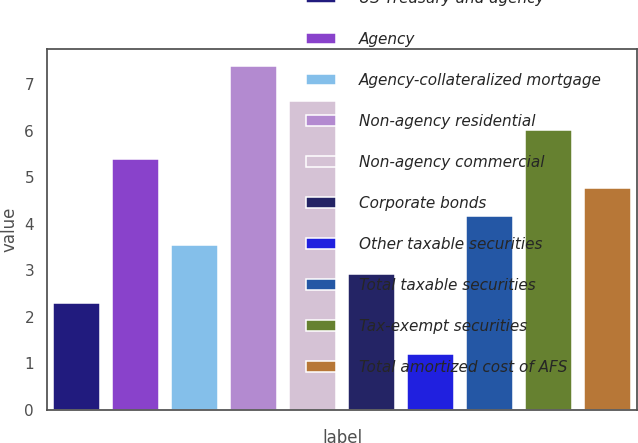Convert chart. <chart><loc_0><loc_0><loc_500><loc_500><bar_chart><fcel>US Treasury and agency<fcel>Agency<fcel>Agency-collateralized mortgage<fcel>Non-agency residential<fcel>Non-agency commercial<fcel>Corporate bonds<fcel>Other taxable securities<fcel>Total taxable securities<fcel>Tax-exempt securities<fcel>Total amortized cost of AFS<nl><fcel>2.3<fcel>5.4<fcel>3.54<fcel>7.4<fcel>6.64<fcel>2.92<fcel>1.2<fcel>4.16<fcel>6.02<fcel>4.78<nl></chart> 